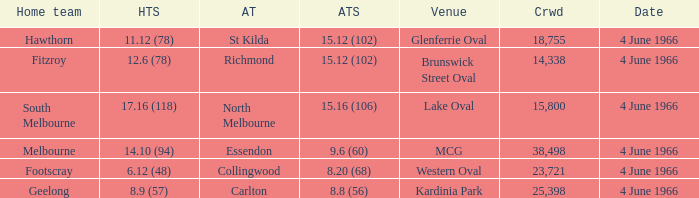What is the average crowd size of the away team who scored 9.6 (60)? 38498.0. 